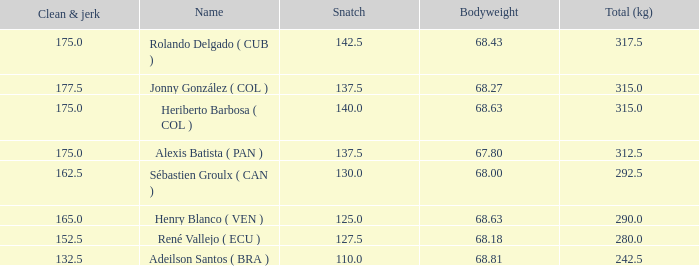Tell me the highest snatch for 68.63 bodyweight and total kg less than 290 None. 